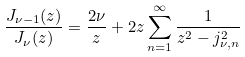Convert formula to latex. <formula><loc_0><loc_0><loc_500><loc_500>\frac { J _ { \nu - 1 } ( z ) } { J _ { \nu } ( z ) } = \frac { 2 \nu } { z } + 2 z \sum _ { n = 1 } ^ { \infty } \frac { 1 } { z ^ { 2 } - j ^ { 2 } _ { \nu , n } }</formula> 